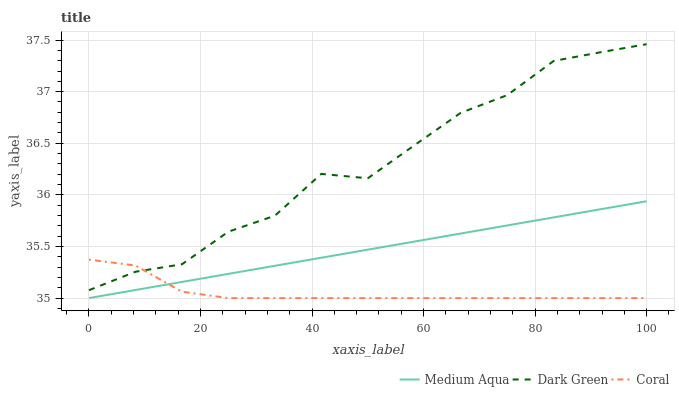Does Coral have the minimum area under the curve?
Answer yes or no. Yes. Does Dark Green have the maximum area under the curve?
Answer yes or no. Yes. Does Medium Aqua have the minimum area under the curve?
Answer yes or no. No. Does Medium Aqua have the maximum area under the curve?
Answer yes or no. No. Is Medium Aqua the smoothest?
Answer yes or no. Yes. Is Dark Green the roughest?
Answer yes or no. Yes. Is Dark Green the smoothest?
Answer yes or no. No. Is Medium Aqua the roughest?
Answer yes or no. No. Does Coral have the lowest value?
Answer yes or no. Yes. Does Dark Green have the lowest value?
Answer yes or no. No. Does Dark Green have the highest value?
Answer yes or no. Yes. Does Medium Aqua have the highest value?
Answer yes or no. No. Is Medium Aqua less than Dark Green?
Answer yes or no. Yes. Is Dark Green greater than Medium Aqua?
Answer yes or no. Yes. Does Coral intersect Dark Green?
Answer yes or no. Yes. Is Coral less than Dark Green?
Answer yes or no. No. Is Coral greater than Dark Green?
Answer yes or no. No. Does Medium Aqua intersect Dark Green?
Answer yes or no. No. 